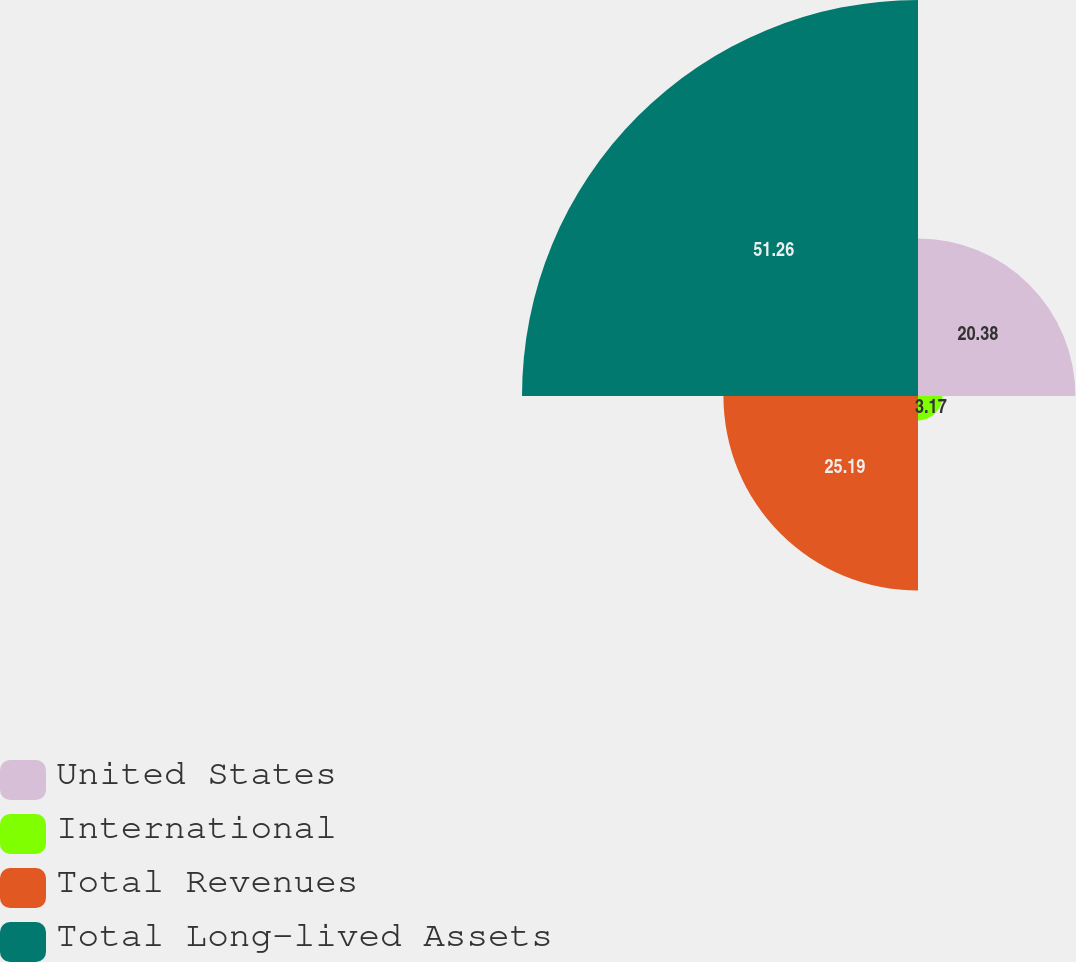Convert chart to OTSL. <chart><loc_0><loc_0><loc_500><loc_500><pie_chart><fcel>United States<fcel>International<fcel>Total Revenues<fcel>Total Long-lived Assets<nl><fcel>20.38%<fcel>3.17%<fcel>25.19%<fcel>51.27%<nl></chart> 